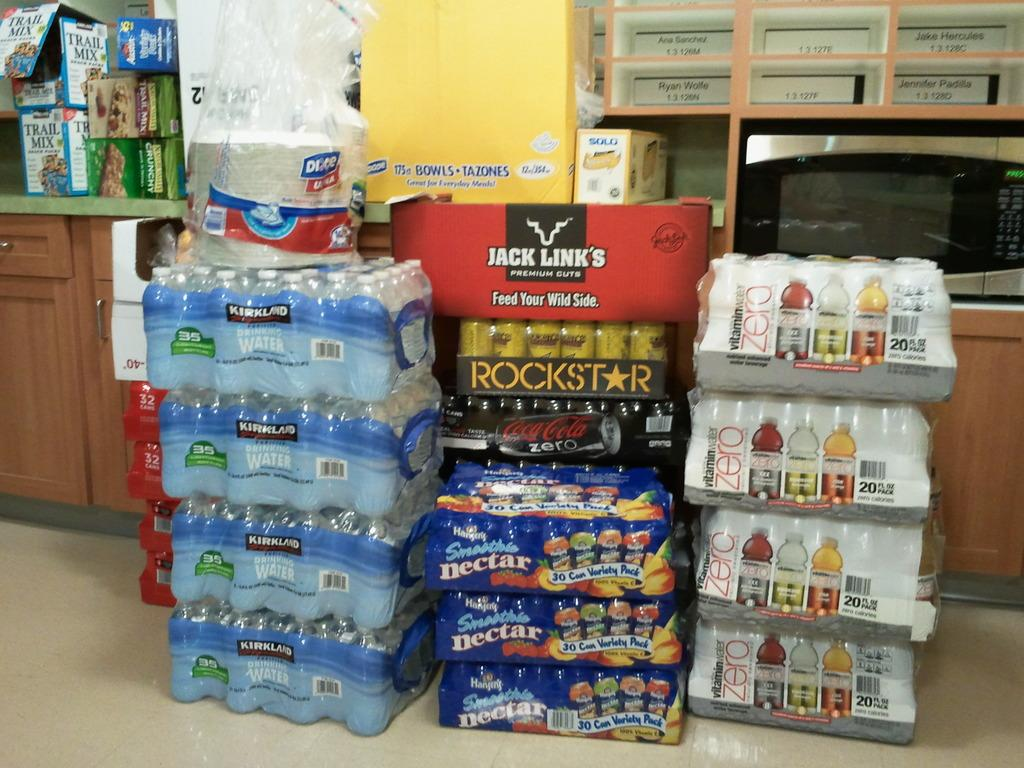<image>
Present a compact description of the photo's key features. A stack of Kirkland water bottles on top of one another. 